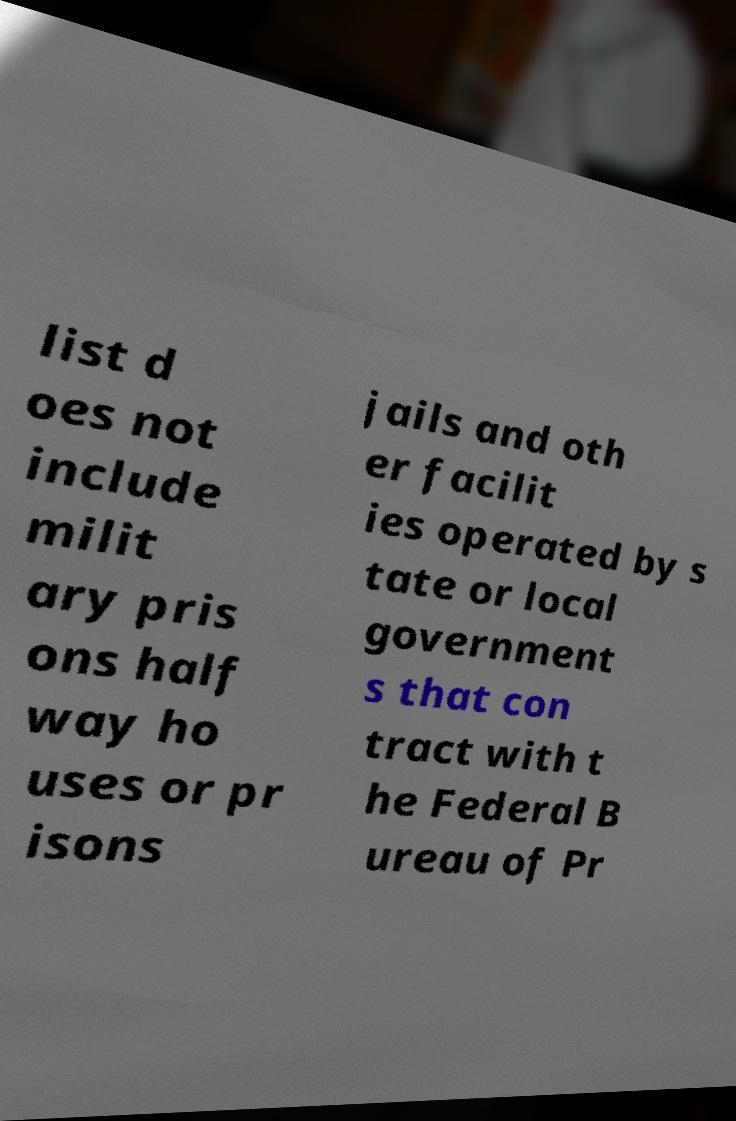Could you extract and type out the text from this image? list d oes not include milit ary pris ons half way ho uses or pr isons jails and oth er facilit ies operated by s tate or local government s that con tract with t he Federal B ureau of Pr 